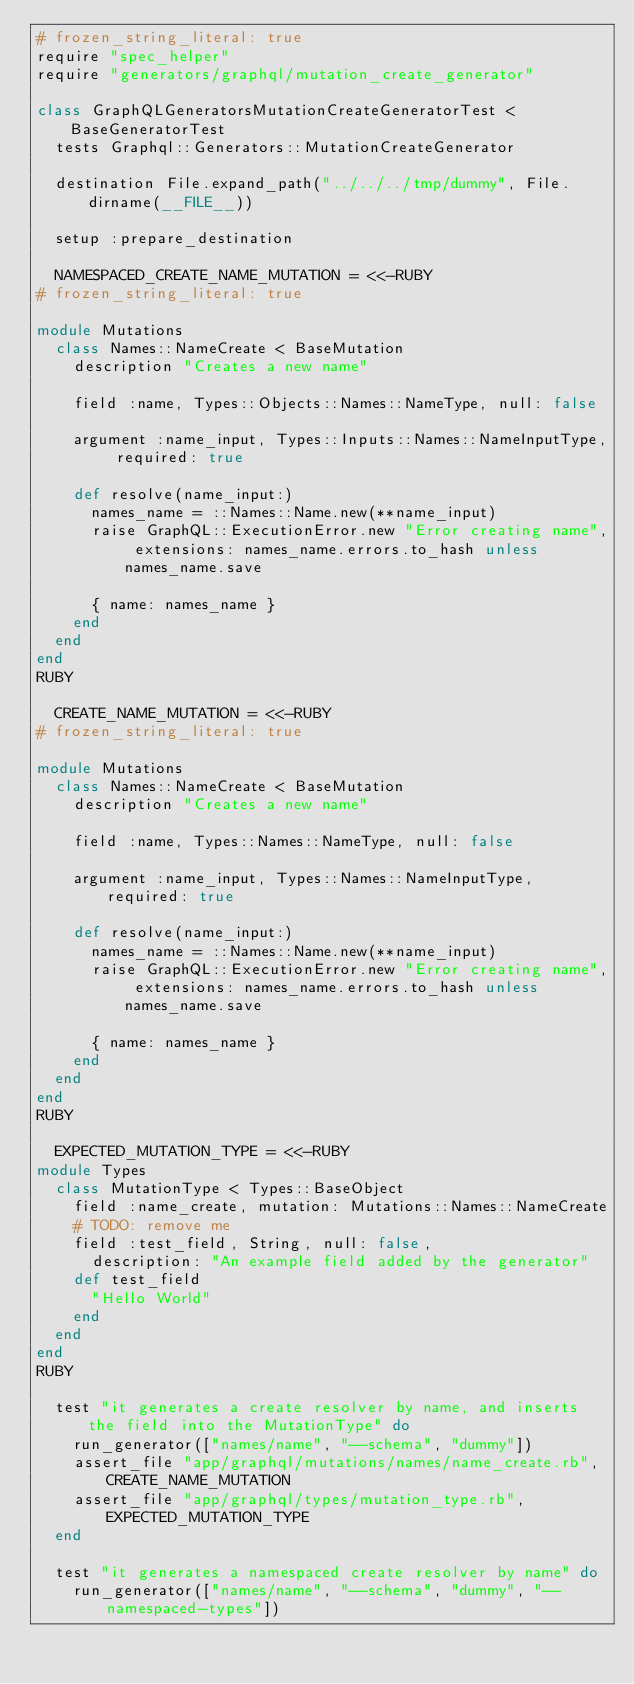<code> <loc_0><loc_0><loc_500><loc_500><_Ruby_># frozen_string_literal: true
require "spec_helper"
require "generators/graphql/mutation_create_generator"

class GraphQLGeneratorsMutationCreateGeneratorTest < BaseGeneratorTest
  tests Graphql::Generators::MutationCreateGenerator

  destination File.expand_path("../../../tmp/dummy", File.dirname(__FILE__))

  setup :prepare_destination

  NAMESPACED_CREATE_NAME_MUTATION = <<-RUBY
# frozen_string_literal: true

module Mutations
  class Names::NameCreate < BaseMutation
    description "Creates a new name"

    field :name, Types::Objects::Names::NameType, null: false

    argument :name_input, Types::Inputs::Names::NameInputType, required: true

    def resolve(name_input:)
      names_name = ::Names::Name.new(**name_input)
      raise GraphQL::ExecutionError.new "Error creating name", extensions: names_name.errors.to_hash unless names_name.save

      { name: names_name }
    end
  end
end
RUBY

  CREATE_NAME_MUTATION = <<-RUBY
# frozen_string_literal: true

module Mutations
  class Names::NameCreate < BaseMutation
    description "Creates a new name"

    field :name, Types::Names::NameType, null: false

    argument :name_input, Types::Names::NameInputType, required: true

    def resolve(name_input:)
      names_name = ::Names::Name.new(**name_input)
      raise GraphQL::ExecutionError.new "Error creating name", extensions: names_name.errors.to_hash unless names_name.save

      { name: names_name }
    end
  end
end
RUBY

  EXPECTED_MUTATION_TYPE = <<-RUBY
module Types
  class MutationType < Types::BaseObject
    field :name_create, mutation: Mutations::Names::NameCreate
    # TODO: remove me
    field :test_field, String, null: false,
      description: "An example field added by the generator"
    def test_field
      "Hello World"
    end
  end
end
RUBY

  test "it generates a create resolver by name, and inserts the field into the MutationType" do
    run_generator(["names/name", "--schema", "dummy"])
    assert_file "app/graphql/mutations/names/name_create.rb", CREATE_NAME_MUTATION
    assert_file "app/graphql/types/mutation_type.rb", EXPECTED_MUTATION_TYPE
  end

  test "it generates a namespaced create resolver by name" do
    run_generator(["names/name", "--schema", "dummy", "--namespaced-types"])</code> 